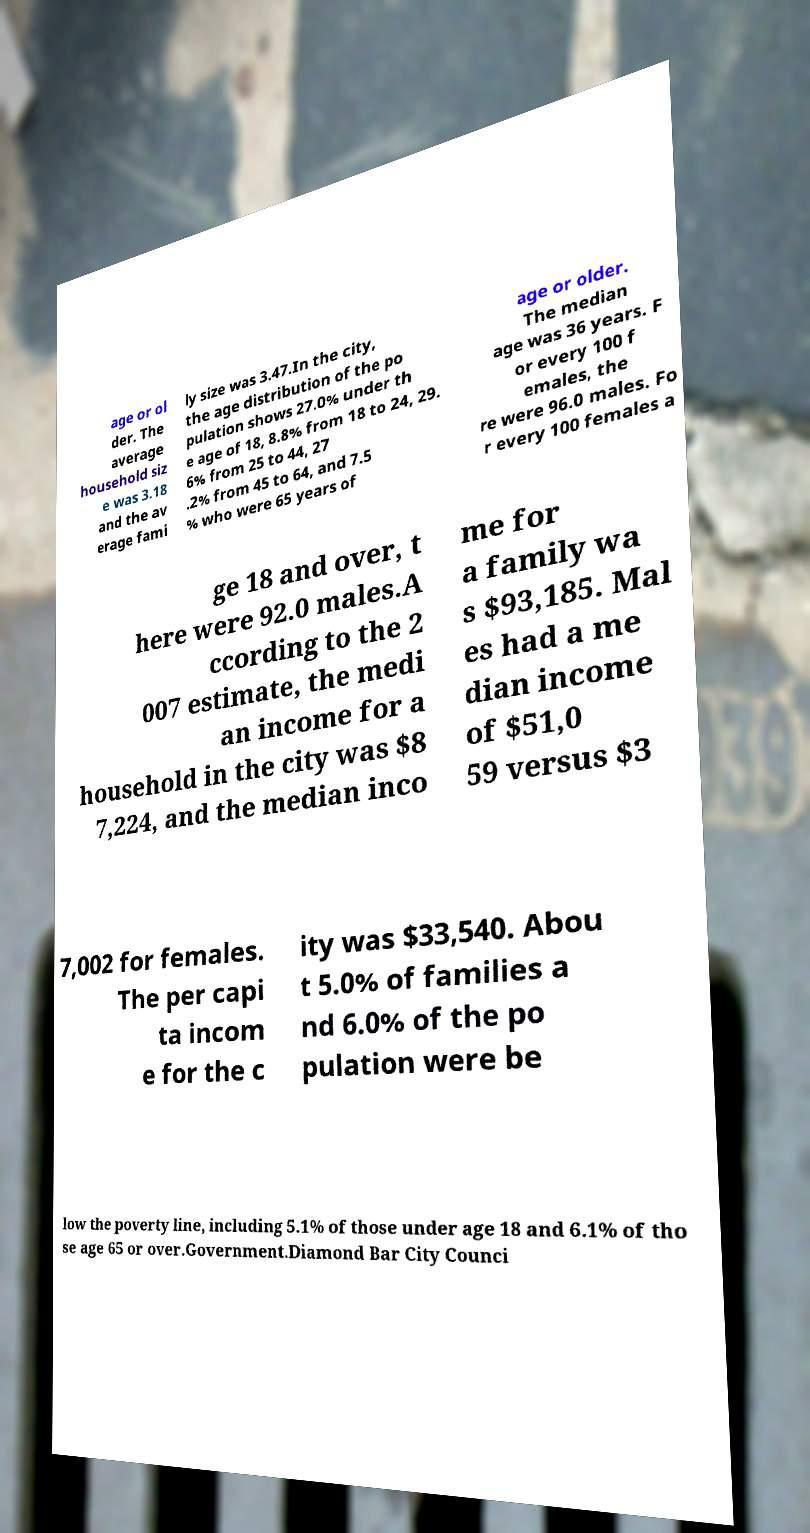Please identify and transcribe the text found in this image. age or ol der. The average household siz e was 3.18 and the av erage fami ly size was 3.47.In the city, the age distribution of the po pulation shows 27.0% under th e age of 18, 8.8% from 18 to 24, 29. 6% from 25 to 44, 27 .2% from 45 to 64, and 7.5 % who were 65 years of age or older. The median age was 36 years. F or every 100 f emales, the re were 96.0 males. Fo r every 100 females a ge 18 and over, t here were 92.0 males.A ccording to the 2 007 estimate, the medi an income for a household in the city was $8 7,224, and the median inco me for a family wa s $93,185. Mal es had a me dian income of $51,0 59 versus $3 7,002 for females. The per capi ta incom e for the c ity was $33,540. Abou t 5.0% of families a nd 6.0% of the po pulation were be low the poverty line, including 5.1% of those under age 18 and 6.1% of tho se age 65 or over.Government.Diamond Bar City Counci 